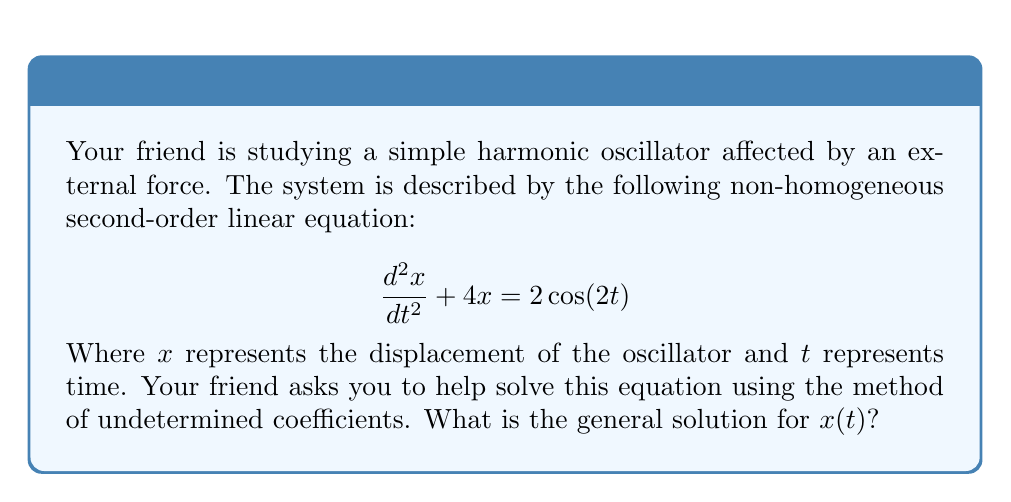Show me your answer to this math problem. Let's solve this step-by-step:

1) First, we need to find the complementary solution $x_c(t)$ to the homogeneous equation:
   $$\frac{d^2x}{dt^2} + 4x = 0$$
   The characteristic equation is $r^2 + 4 = 0$, which gives $r = \pm 2i$.
   So, $x_c(t) = c_1\cos(2t) + c_2\sin(2t)$

2) Now, we need to find the particular solution $x_p(t)$. Since $2\cos(2t)$ is on the right side of the equation and $\cos(2t)$ is already in the complementary solution, we assume:
   $$x_p(t) = At\cos(2t) + Bt\sin(2t)$$

3) We differentiate $x_p(t)$ twice:
   $$\frac{dx_p}{dt} = A\cos(2t) - 2At\sin(2t) + B\sin(2t) + 2Bt\cos(2t)$$
   $$\frac{d^2x_p}{dt^2} = -4A\sin(2t) - 4At\cos(2t) + 4B\cos(2t) - 4Bt\sin(2t)$$

4) Substitute these into the original equation:
   $$(-4A\sin(2t) - 4At\cos(2t) + 4B\cos(2t) - 4Bt\sin(2t)) + 4(At\cos(2t) + Bt\sin(2t)) = 2\cos(2t)$$

5) Simplify:
   $$-4A\sin(2t) + 4B\cos(2t) = 2\cos(2t)$$

6) Equate coefficients:
   $$\begin{cases}
   4B = 2 \\
   -4A = 0
   \end{cases}$$

7) Solve for A and B:
   $$A = 0, B = \frac{1}{2}$$

8) Therefore, the particular solution is:
   $$x_p(t) = \frac{1}{2}t\sin(2t)$$

9) The general solution is the sum of the complementary and particular solutions:
   $$x(t) = x_c(t) + x_p(t) = c_1\cos(2t) + c_2\sin(2t) + \frac{1}{2}t\sin(2t)$$
Answer: $x(t) = c_1\cos(2t) + c_2\sin(2t) + \frac{1}{2}t\sin(2t)$ 